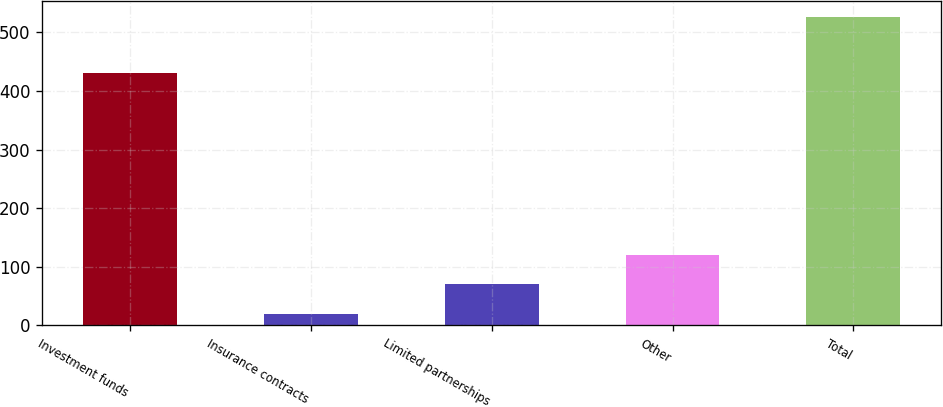<chart> <loc_0><loc_0><loc_500><loc_500><bar_chart><fcel>Investment funds<fcel>Insurance contracts<fcel>Limited partnerships<fcel>Other<fcel>Total<nl><fcel>431.5<fcel>19.3<fcel>70.07<fcel>120.84<fcel>527<nl></chart> 